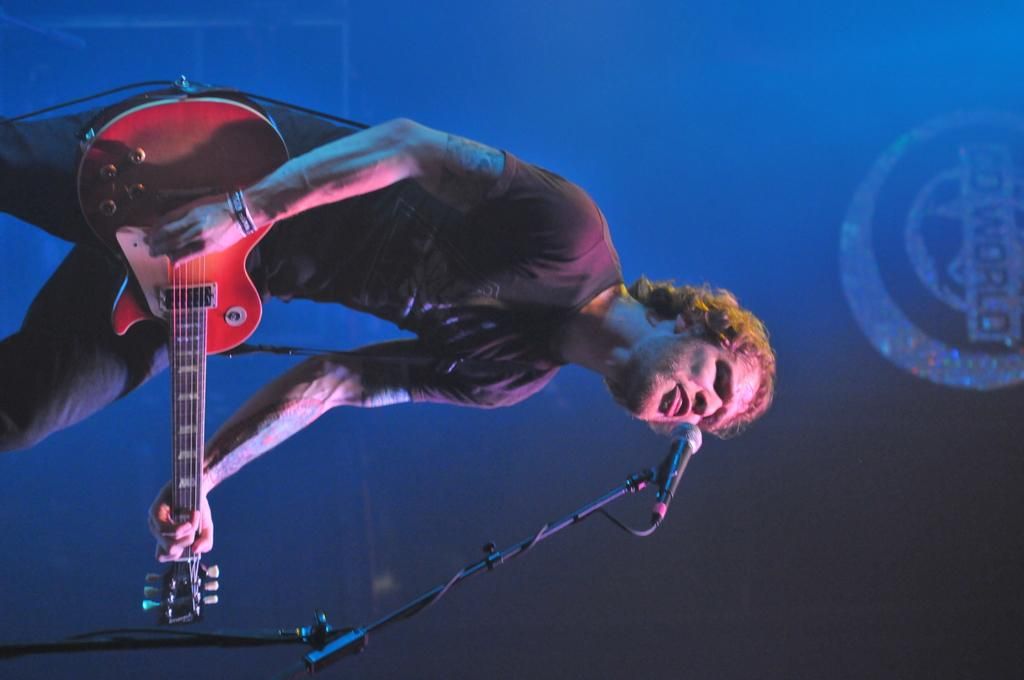What is the person in the image doing? The person is playing a musical instrument in the image. What object is present that might be used for amplifying the person's voice? There is a microphone in the image. What can be seen in the background of the image? There is text visible in the background of the image. Where is the goat wearing a crown in the image? There is no goat or crown present in the image. 